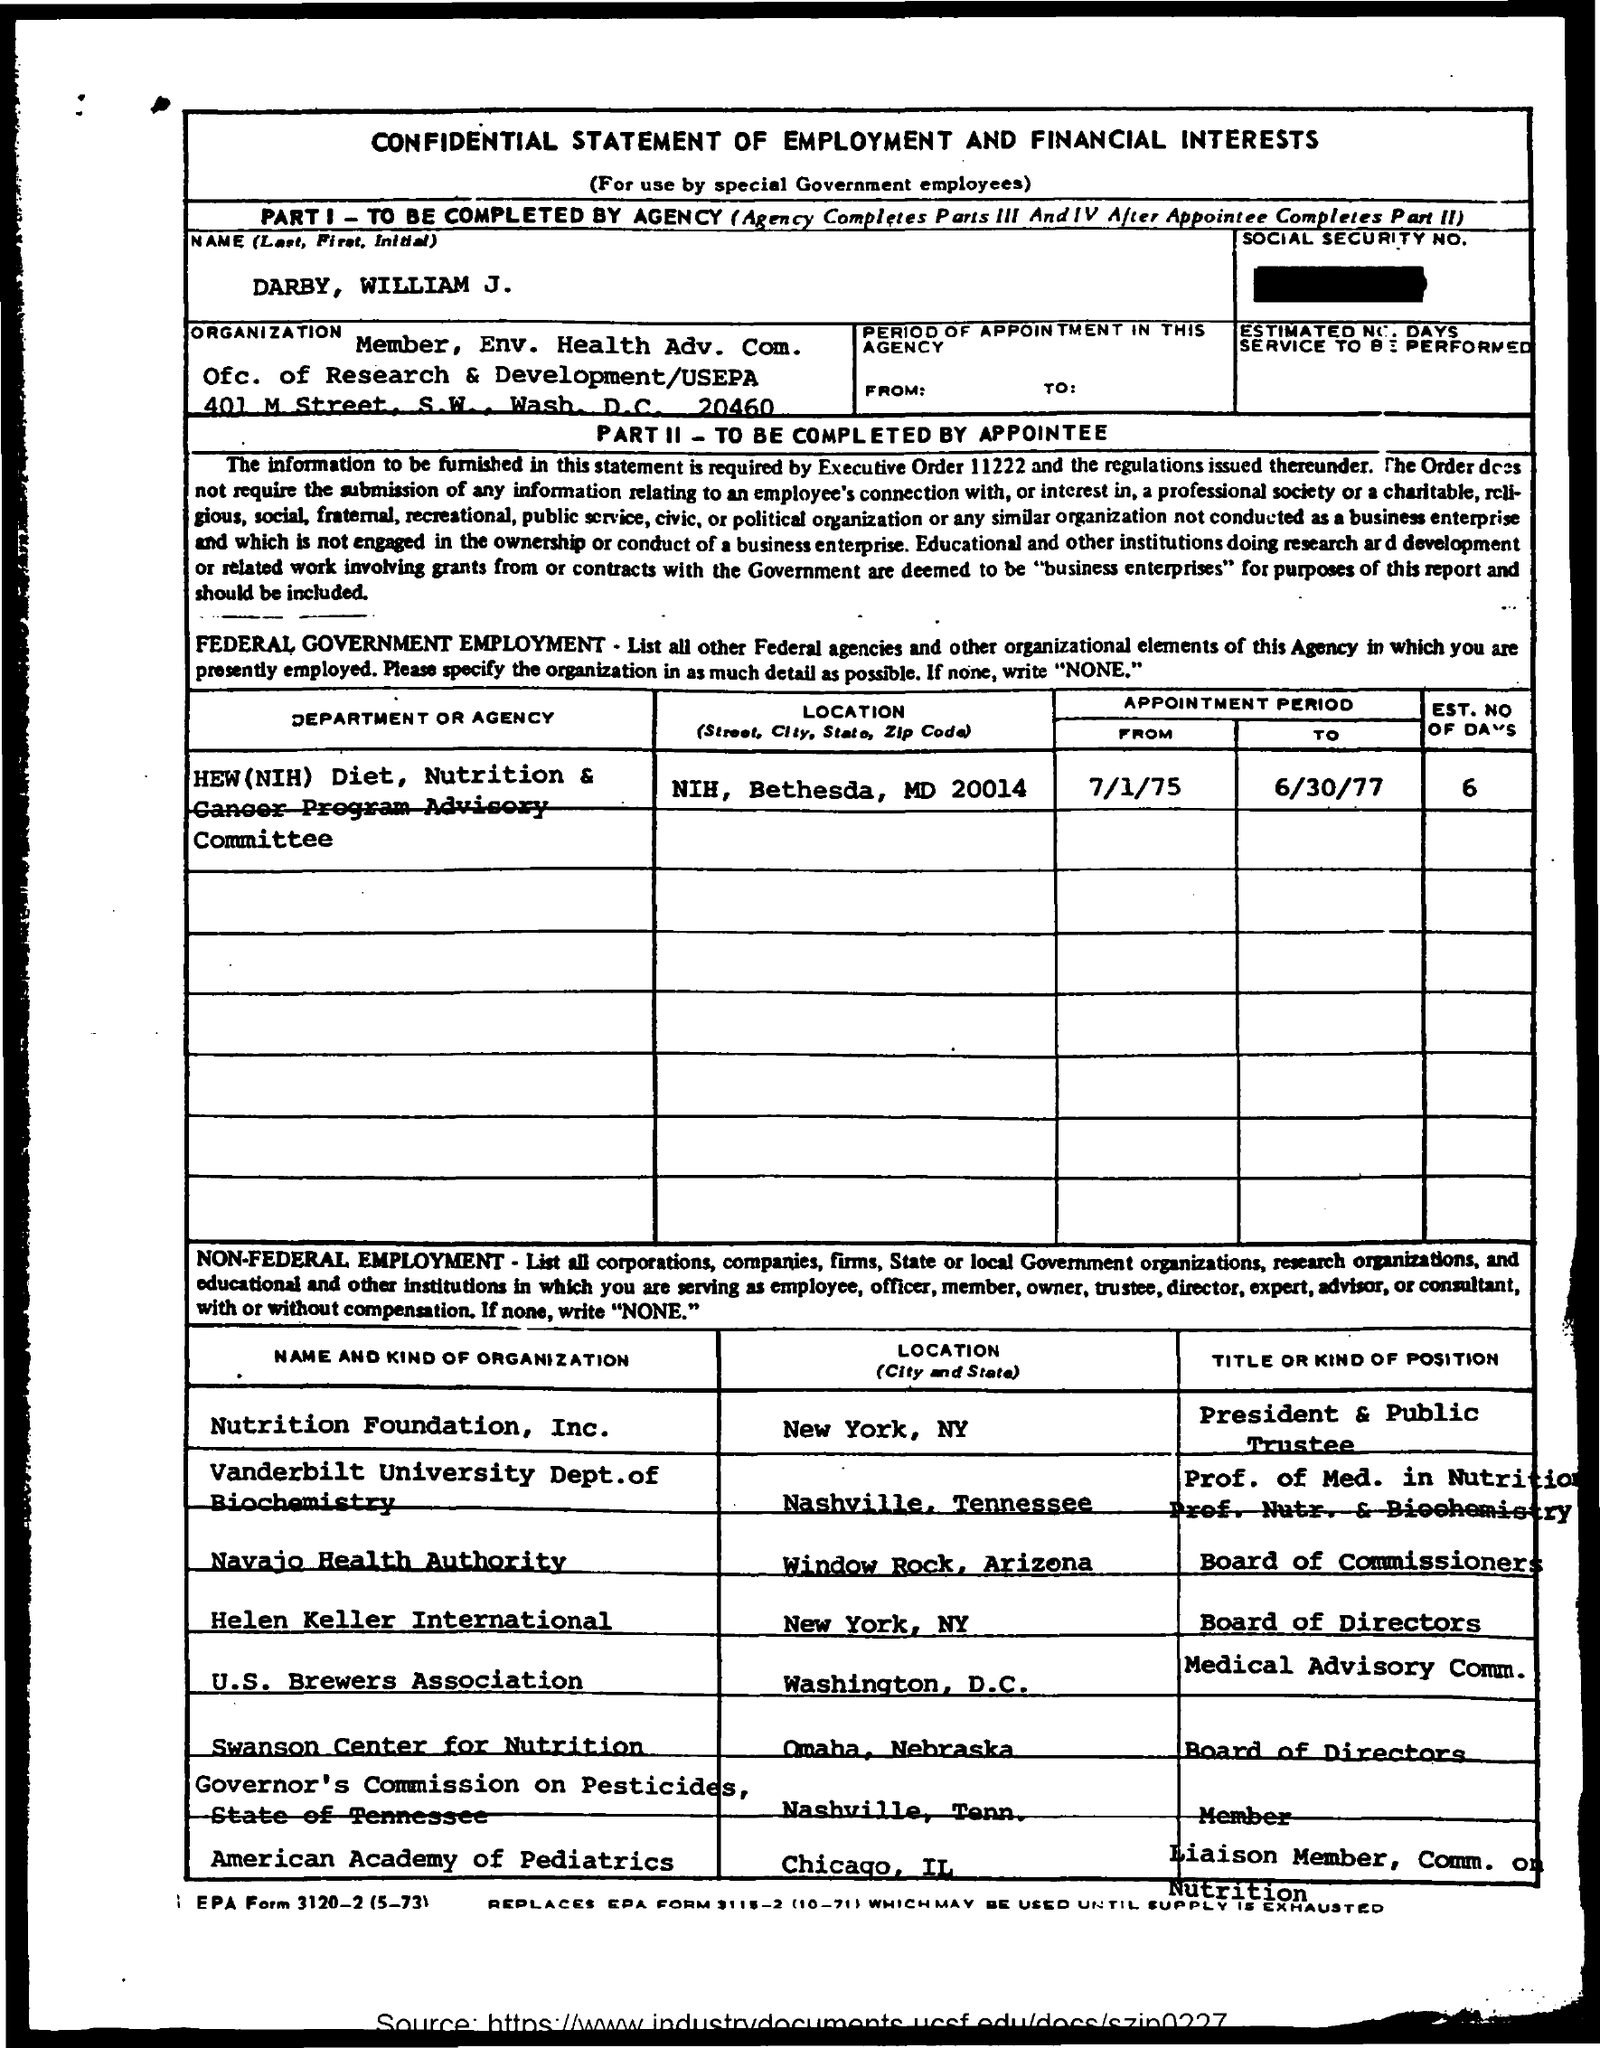Which "STATEMENT" is this?
Offer a terse response. CONFIDENTIAL STATEMENT OF EMPLOYMENT AND FINANCIAL INTERESTS. What is NAME mentioned?
Your answer should be very brief. Darby, William J. Mention the location of "Nutrition Foundation, Inc."?
Ensure brevity in your answer.  New York, NY. Mention the location of "U.S. Brewers Association"?
Provide a succinct answer. Washington, D.C. Mention the location of "American Academy of Pediatrics"?
Keep it short and to the point. Chicago, IL. Mention the location of "Swanson Center for Nutrition"?
Make the answer very short. Omaha, Nebraska. Mention the location of "Helen Keller International?
Your answer should be very brief. New York,  NY. Mention the "EST. NO OF DAYS"  for  "HEW(NIH) Diet"?
Ensure brevity in your answer.  6. 